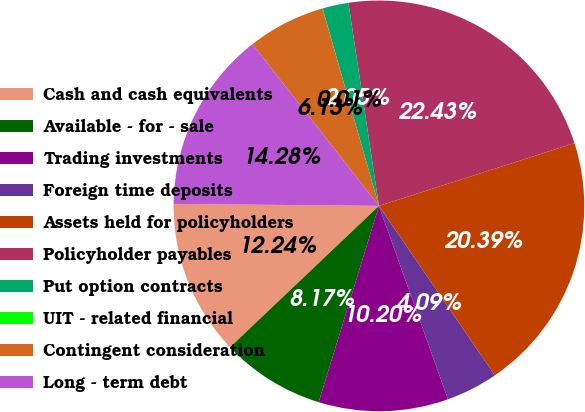<chart> <loc_0><loc_0><loc_500><loc_500><pie_chart><fcel>Cash and cash equivalents<fcel>Available - for - sale<fcel>Trading investments<fcel>Foreign time deposits<fcel>Assets held for policyholders<fcel>Policyholder payables<fcel>Put option contracts<fcel>UIT - related financial<fcel>Contingent consideration<fcel>Long - term debt<nl><fcel>12.24%<fcel>8.17%<fcel>10.2%<fcel>4.09%<fcel>20.39%<fcel>22.43%<fcel>2.05%<fcel>0.01%<fcel>6.13%<fcel>14.28%<nl></chart> 